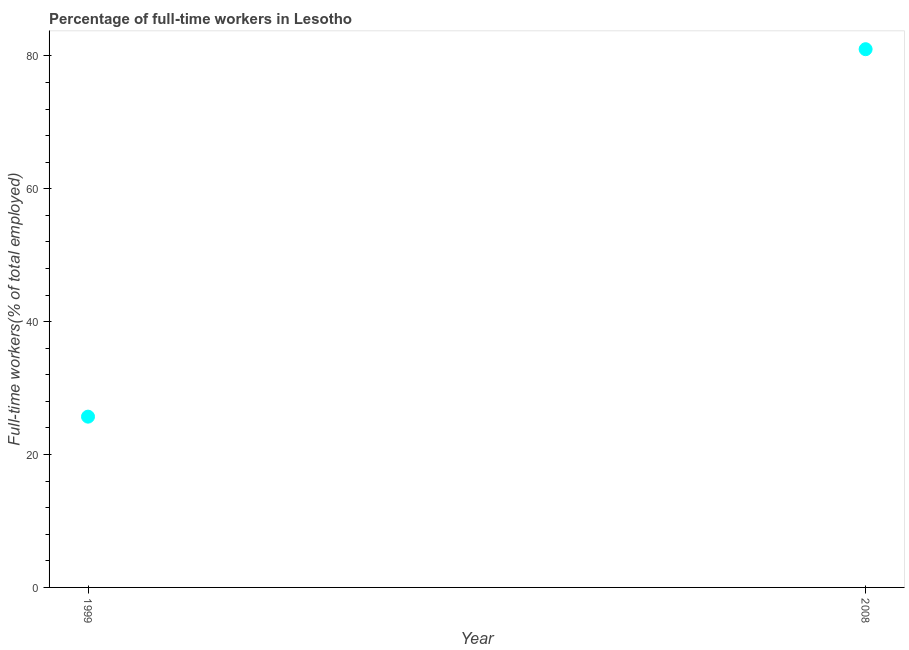What is the percentage of full-time workers in 2008?
Offer a terse response. 81. Across all years, what is the maximum percentage of full-time workers?
Keep it short and to the point. 81. Across all years, what is the minimum percentage of full-time workers?
Provide a short and direct response. 25.7. In which year was the percentage of full-time workers minimum?
Provide a short and direct response. 1999. What is the sum of the percentage of full-time workers?
Your response must be concise. 106.7. What is the difference between the percentage of full-time workers in 1999 and 2008?
Give a very brief answer. -55.3. What is the average percentage of full-time workers per year?
Give a very brief answer. 53.35. What is the median percentage of full-time workers?
Provide a short and direct response. 53.35. What is the ratio of the percentage of full-time workers in 1999 to that in 2008?
Provide a short and direct response. 0.32. Is the percentage of full-time workers in 1999 less than that in 2008?
Give a very brief answer. Yes. How many dotlines are there?
Provide a short and direct response. 1. How many years are there in the graph?
Your response must be concise. 2. What is the difference between two consecutive major ticks on the Y-axis?
Make the answer very short. 20. Are the values on the major ticks of Y-axis written in scientific E-notation?
Ensure brevity in your answer.  No. Does the graph contain any zero values?
Give a very brief answer. No. Does the graph contain grids?
Provide a succinct answer. No. What is the title of the graph?
Keep it short and to the point. Percentage of full-time workers in Lesotho. What is the label or title of the Y-axis?
Offer a terse response. Full-time workers(% of total employed). What is the Full-time workers(% of total employed) in 1999?
Your answer should be very brief. 25.7. What is the difference between the Full-time workers(% of total employed) in 1999 and 2008?
Give a very brief answer. -55.3. What is the ratio of the Full-time workers(% of total employed) in 1999 to that in 2008?
Provide a short and direct response. 0.32. 